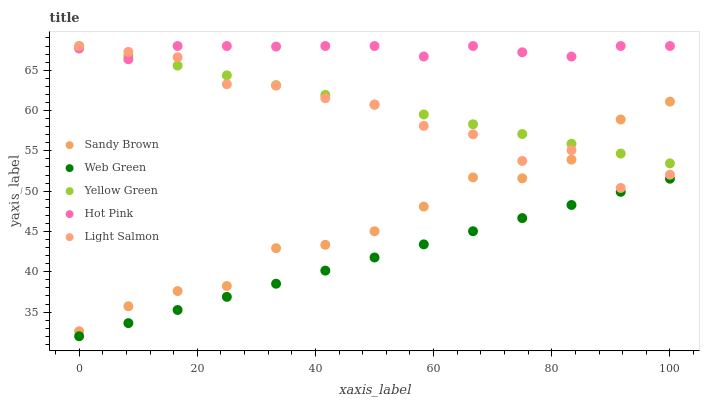Does Web Green have the minimum area under the curve?
Answer yes or no. Yes. Does Hot Pink have the maximum area under the curve?
Answer yes or no. Yes. Does Sandy Brown have the minimum area under the curve?
Answer yes or no. No. Does Sandy Brown have the maximum area under the curve?
Answer yes or no. No. Is Web Green the smoothest?
Answer yes or no. Yes. Is Light Salmon the roughest?
Answer yes or no. Yes. Is Hot Pink the smoothest?
Answer yes or no. No. Is Hot Pink the roughest?
Answer yes or no. No. Does Web Green have the lowest value?
Answer yes or no. Yes. Does Sandy Brown have the lowest value?
Answer yes or no. No. Does Yellow Green have the highest value?
Answer yes or no. Yes. Does Sandy Brown have the highest value?
Answer yes or no. No. Is Sandy Brown less than Hot Pink?
Answer yes or no. Yes. Is Yellow Green greater than Web Green?
Answer yes or no. Yes. Does Yellow Green intersect Light Salmon?
Answer yes or no. Yes. Is Yellow Green less than Light Salmon?
Answer yes or no. No. Is Yellow Green greater than Light Salmon?
Answer yes or no. No. Does Sandy Brown intersect Hot Pink?
Answer yes or no. No. 